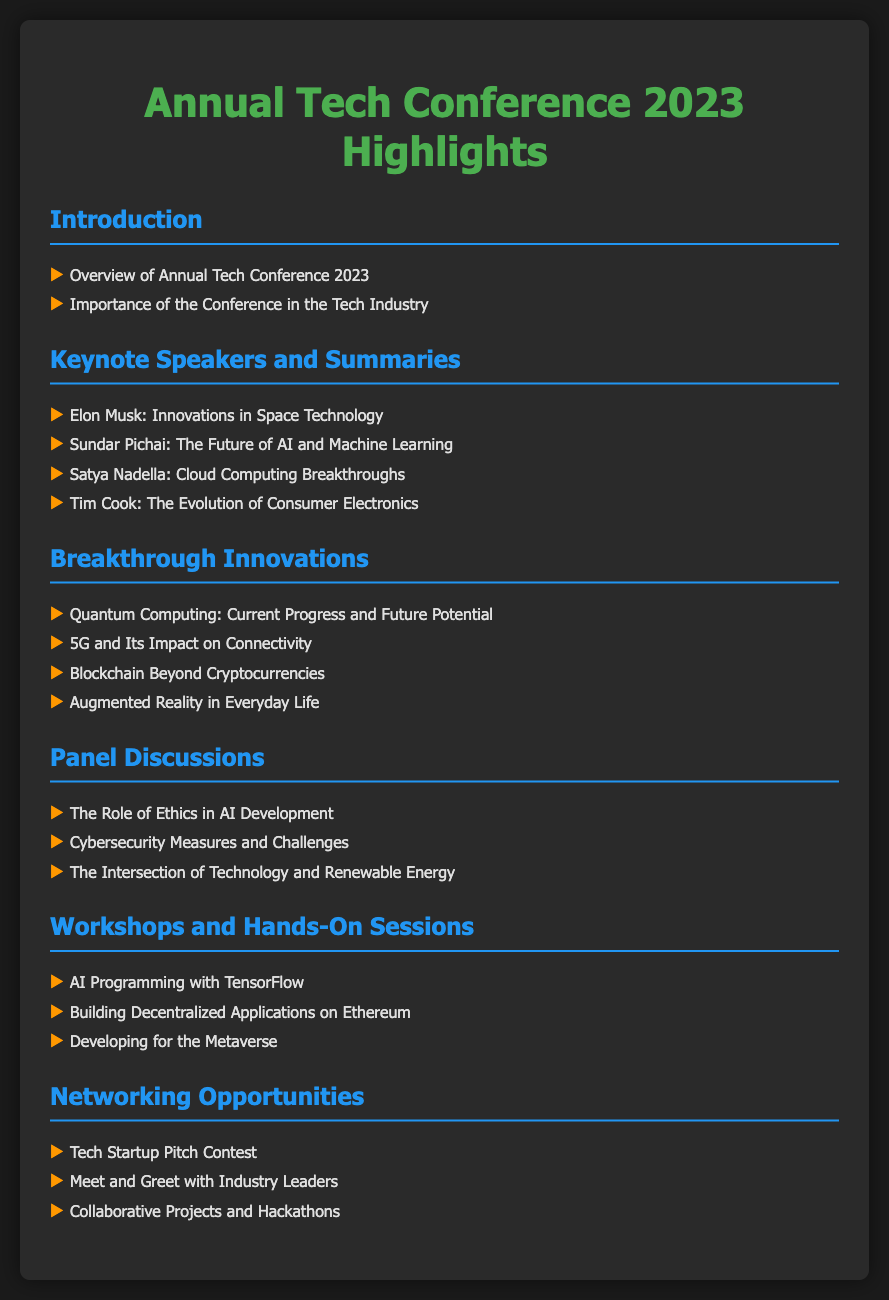what is the title of the conference? The title of the conference is found at the top of the document, which is the "Annual Tech Conference 2023 Highlights."
Answer: Annual Tech Conference 2023 Highlights who is one of the keynote speakers discussing AI? The document lists Sundar Pichai as one of the keynote speakers focusing on AI and Machine Learning.
Answer: Sundar Pichai how many keynote speakers are mentioned? The count of keynote speakers can be determined by the number of different names listed in the section for Keynote Speakers and Summaries. There are four speakers.
Answer: 4 what innovative technology is highlighted under Breakthrough Innovations? One of the highlighted innovations is Quantum Computing, as listed under Breakthrough Innovations.
Answer: Quantum Computing which panel discussion addresses cybersecurity? The panel discussion specifically about cybersecurity measures is mentioned under the Panel Discussions section.
Answer: Cybersecurity Measures and Challenges what workshop focuses on building applications? The workshop dedicated to the development of decentralized applications is listed under Workshops and Hands-On Sessions.
Answer: Building Decentralized Applications on Ethereum what networking opportunity includes industry leaders? The networking opportunity that features interaction with industry leaders is listed as a "Meet and Greet with Industry Leaders."
Answer: Meet and Greet with Industry Leaders what topic discusses renewable energy and technology? The topic that combines renewable energy with technology is mentioned in the panel discussions.
Answer: The Intersection of Technology and Renewable Energy 